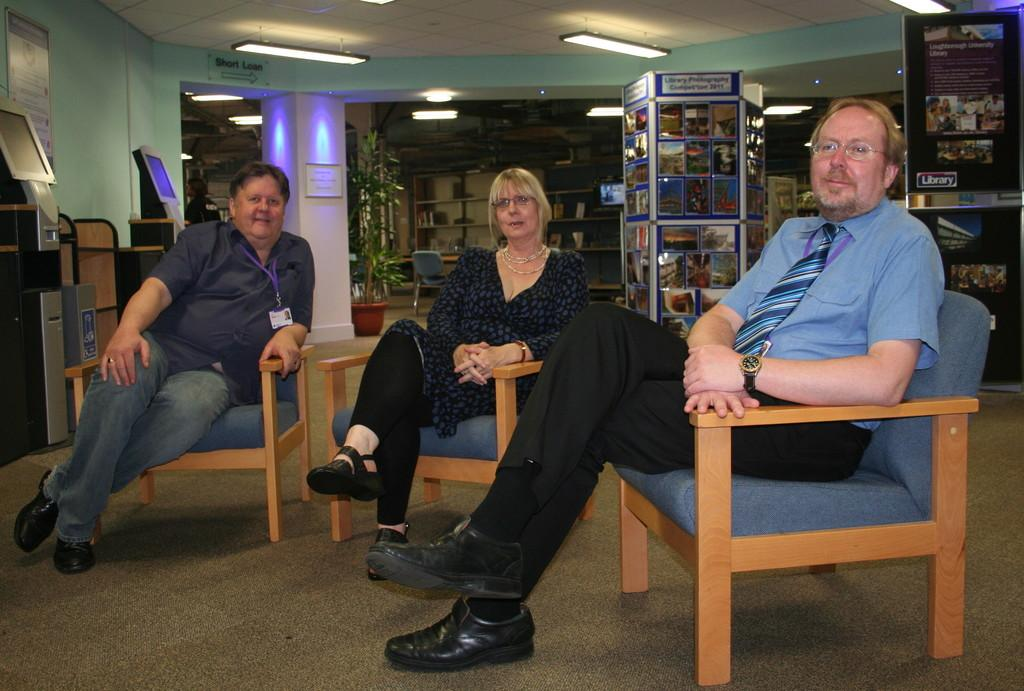What can be found on the racks in the image? The racks are filled with books. How many people are sitting on the chair in the image? Three persons are sitting on a chair. What is located above the people in the image? There are lights on top. What is present on the wall in the image? There is an information board on the wall. What additional feature is visible in the image? There is a banner. What type of letter is being handed out in the image? There is no letter being handed out in the image; the focus is on the racks filled with books, the people sitting on the chair, the lights on top, the information board on the wall, and the banner. What color is the silverware on the table in the image? There is no table or silverware present in the image. 